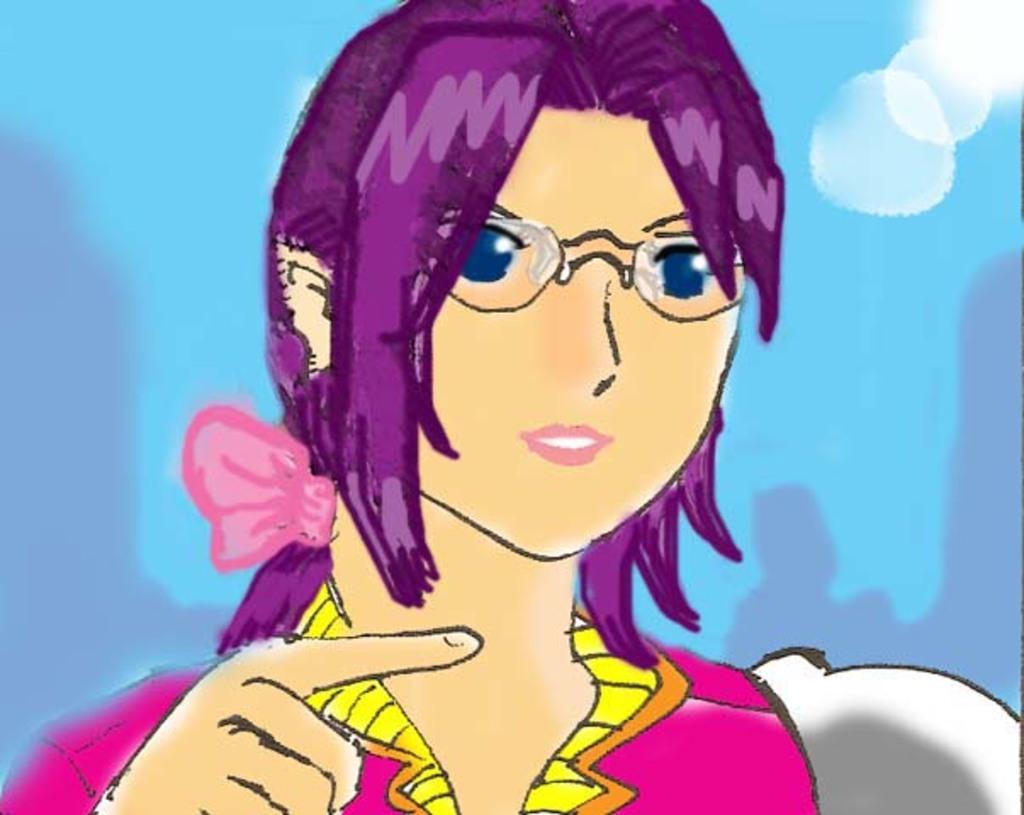Could you give a brief overview of what you see in this image? This looks like an animated image. This is the woman. She wore a dress and spectacles. The background looks blue in color. 